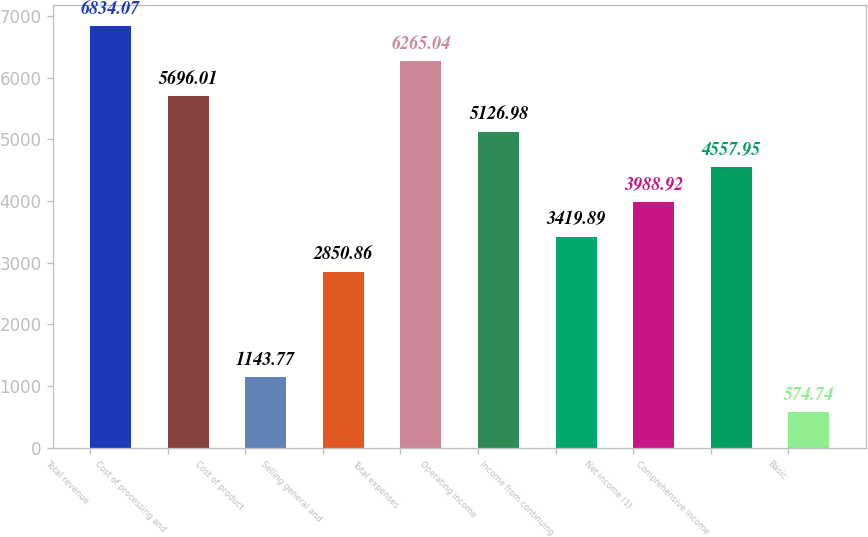<chart> <loc_0><loc_0><loc_500><loc_500><bar_chart><fcel>Total revenue<fcel>Cost of processing and<fcel>Cost of product<fcel>Selling general and<fcel>Total expenses<fcel>Operating income<fcel>Income from continuing<fcel>Net income (1)<fcel>Comprehensive income<fcel>Basic<nl><fcel>6834.07<fcel>5696.01<fcel>1143.77<fcel>2850.86<fcel>6265.04<fcel>5126.98<fcel>3419.89<fcel>3988.92<fcel>4557.95<fcel>574.74<nl></chart> 